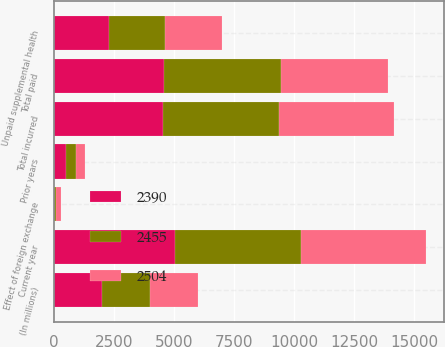Convert chart to OTSL. <chart><loc_0><loc_0><loc_500><loc_500><stacked_bar_chart><ecel><fcel>(In millions)<fcel>Unpaid supplemental health<fcel>Current year<fcel>Prior years<fcel>Total incurred<fcel>Total paid<fcel>Effect of foreign exchange<nl><fcel>2455<fcel>2007<fcel>2332<fcel>5225<fcel>401<fcel>4824<fcel>4857<fcel>72<nl><fcel>2390<fcel>2006<fcel>2293<fcel>5045<fcel>516<fcel>4529<fcel>4597<fcel>14<nl><fcel>2504<fcel>2005<fcel>2375<fcel>5203<fcel>401<fcel>4802<fcel>4458<fcel>199<nl></chart> 